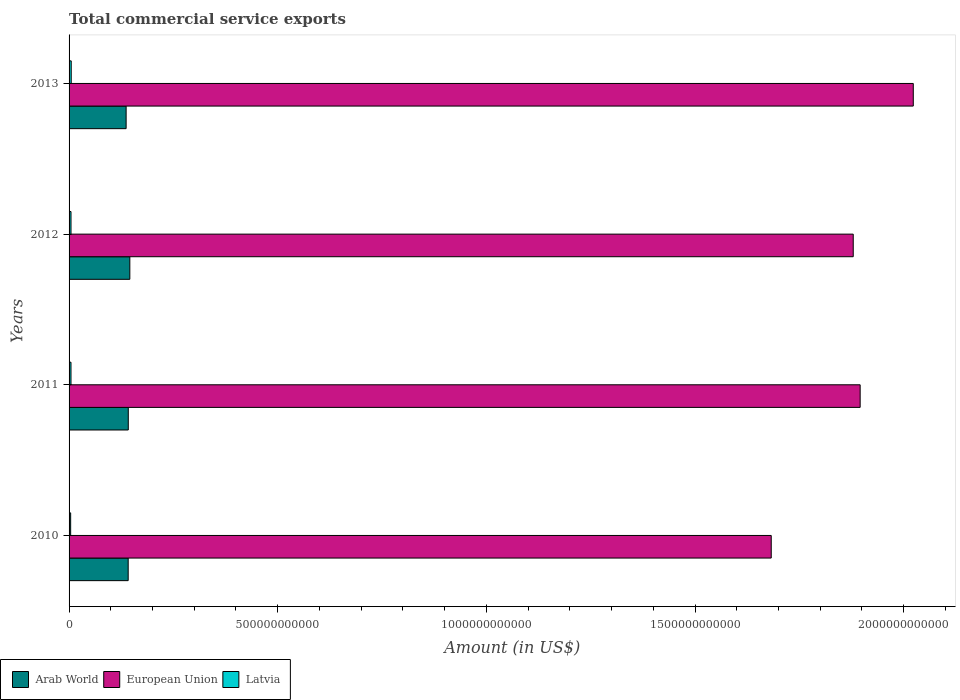How many different coloured bars are there?
Provide a succinct answer. 3. Are the number of bars per tick equal to the number of legend labels?
Make the answer very short. Yes. How many bars are there on the 4th tick from the top?
Make the answer very short. 3. How many bars are there on the 4th tick from the bottom?
Give a very brief answer. 3. What is the label of the 2nd group of bars from the top?
Make the answer very short. 2012. In how many cases, is the number of bars for a given year not equal to the number of legend labels?
Ensure brevity in your answer.  0. What is the total commercial service exports in European Union in 2012?
Make the answer very short. 1.88e+12. Across all years, what is the maximum total commercial service exports in Arab World?
Keep it short and to the point. 1.46e+11. Across all years, what is the minimum total commercial service exports in Latvia?
Your response must be concise. 3.78e+09. In which year was the total commercial service exports in Latvia minimum?
Your response must be concise. 2010. What is the total total commercial service exports in Arab World in the graph?
Provide a succinct answer. 5.66e+11. What is the difference between the total commercial service exports in Arab World in 2010 and that in 2013?
Your answer should be compact. 4.95e+09. What is the difference between the total commercial service exports in European Union in 2013 and the total commercial service exports in Arab World in 2012?
Provide a succinct answer. 1.88e+12. What is the average total commercial service exports in Latvia per year?
Your answer should be very brief. 4.54e+09. In the year 2012, what is the difference between the total commercial service exports in Latvia and total commercial service exports in European Union?
Your answer should be very brief. -1.87e+12. What is the ratio of the total commercial service exports in Arab World in 2012 to that in 2013?
Your answer should be very brief. 1.06. Is the difference between the total commercial service exports in Latvia in 2011 and 2012 greater than the difference between the total commercial service exports in European Union in 2011 and 2012?
Make the answer very short. No. What is the difference between the highest and the second highest total commercial service exports in European Union?
Your answer should be compact. 1.27e+11. What is the difference between the highest and the lowest total commercial service exports in Latvia?
Your response must be concise. 1.36e+09. Is the sum of the total commercial service exports in European Union in 2010 and 2011 greater than the maximum total commercial service exports in Latvia across all years?
Provide a short and direct response. Yes. What does the 1st bar from the top in 2012 represents?
Your answer should be compact. Latvia. What does the 3rd bar from the bottom in 2012 represents?
Provide a succinct answer. Latvia. How many bars are there?
Make the answer very short. 12. How many years are there in the graph?
Make the answer very short. 4. What is the difference between two consecutive major ticks on the X-axis?
Keep it short and to the point. 5.00e+11. Are the values on the major ticks of X-axis written in scientific E-notation?
Your answer should be compact. No. Does the graph contain grids?
Give a very brief answer. No. How many legend labels are there?
Provide a succinct answer. 3. What is the title of the graph?
Your answer should be compact. Total commercial service exports. What is the label or title of the Y-axis?
Offer a very short reply. Years. What is the Amount (in US$) of Arab World in 2010?
Keep it short and to the point. 1.42e+11. What is the Amount (in US$) of European Union in 2010?
Your answer should be compact. 1.68e+12. What is the Amount (in US$) in Latvia in 2010?
Your answer should be compact. 3.78e+09. What is the Amount (in US$) in Arab World in 2011?
Make the answer very short. 1.42e+11. What is the Amount (in US$) in European Union in 2011?
Your answer should be compact. 1.90e+12. What is the Amount (in US$) in Latvia in 2011?
Your answer should be compact. 4.58e+09. What is the Amount (in US$) in Arab World in 2012?
Your answer should be very brief. 1.46e+11. What is the Amount (in US$) in European Union in 2012?
Provide a short and direct response. 1.88e+12. What is the Amount (in US$) in Latvia in 2012?
Provide a short and direct response. 4.64e+09. What is the Amount (in US$) in Arab World in 2013?
Your answer should be compact. 1.37e+11. What is the Amount (in US$) of European Union in 2013?
Keep it short and to the point. 2.02e+12. What is the Amount (in US$) of Latvia in 2013?
Provide a succinct answer. 5.14e+09. Across all years, what is the maximum Amount (in US$) in Arab World?
Ensure brevity in your answer.  1.46e+11. Across all years, what is the maximum Amount (in US$) of European Union?
Offer a very short reply. 2.02e+12. Across all years, what is the maximum Amount (in US$) of Latvia?
Offer a terse response. 5.14e+09. Across all years, what is the minimum Amount (in US$) of Arab World?
Provide a succinct answer. 1.37e+11. Across all years, what is the minimum Amount (in US$) of European Union?
Give a very brief answer. 1.68e+12. Across all years, what is the minimum Amount (in US$) of Latvia?
Offer a terse response. 3.78e+09. What is the total Amount (in US$) of Arab World in the graph?
Make the answer very short. 5.66e+11. What is the total Amount (in US$) in European Union in the graph?
Your response must be concise. 7.48e+12. What is the total Amount (in US$) in Latvia in the graph?
Offer a terse response. 1.81e+1. What is the difference between the Amount (in US$) of Arab World in 2010 and that in 2011?
Give a very brief answer. -2.50e+08. What is the difference between the Amount (in US$) in European Union in 2010 and that in 2011?
Your answer should be compact. -2.13e+11. What is the difference between the Amount (in US$) in Latvia in 2010 and that in 2011?
Keep it short and to the point. -7.96e+08. What is the difference between the Amount (in US$) in Arab World in 2010 and that in 2012?
Offer a terse response. -3.93e+09. What is the difference between the Amount (in US$) of European Union in 2010 and that in 2012?
Ensure brevity in your answer.  -1.96e+11. What is the difference between the Amount (in US$) in Latvia in 2010 and that in 2012?
Make the answer very short. -8.55e+08. What is the difference between the Amount (in US$) in Arab World in 2010 and that in 2013?
Provide a short and direct response. 4.95e+09. What is the difference between the Amount (in US$) of European Union in 2010 and that in 2013?
Give a very brief answer. -3.40e+11. What is the difference between the Amount (in US$) of Latvia in 2010 and that in 2013?
Provide a succinct answer. -1.36e+09. What is the difference between the Amount (in US$) of Arab World in 2011 and that in 2012?
Offer a terse response. -3.68e+09. What is the difference between the Amount (in US$) in European Union in 2011 and that in 2012?
Your response must be concise. 1.66e+1. What is the difference between the Amount (in US$) of Latvia in 2011 and that in 2012?
Provide a short and direct response. -5.86e+07. What is the difference between the Amount (in US$) of Arab World in 2011 and that in 2013?
Ensure brevity in your answer.  5.20e+09. What is the difference between the Amount (in US$) in European Union in 2011 and that in 2013?
Ensure brevity in your answer.  -1.27e+11. What is the difference between the Amount (in US$) in Latvia in 2011 and that in 2013?
Make the answer very short. -5.62e+08. What is the difference between the Amount (in US$) of Arab World in 2012 and that in 2013?
Your answer should be very brief. 8.88e+09. What is the difference between the Amount (in US$) of European Union in 2012 and that in 2013?
Your answer should be compact. -1.44e+11. What is the difference between the Amount (in US$) in Latvia in 2012 and that in 2013?
Your answer should be very brief. -5.04e+08. What is the difference between the Amount (in US$) of Arab World in 2010 and the Amount (in US$) of European Union in 2011?
Offer a very short reply. -1.75e+12. What is the difference between the Amount (in US$) in Arab World in 2010 and the Amount (in US$) in Latvia in 2011?
Provide a succinct answer. 1.37e+11. What is the difference between the Amount (in US$) of European Union in 2010 and the Amount (in US$) of Latvia in 2011?
Give a very brief answer. 1.68e+12. What is the difference between the Amount (in US$) in Arab World in 2010 and the Amount (in US$) in European Union in 2012?
Make the answer very short. -1.74e+12. What is the difference between the Amount (in US$) of Arab World in 2010 and the Amount (in US$) of Latvia in 2012?
Ensure brevity in your answer.  1.37e+11. What is the difference between the Amount (in US$) in European Union in 2010 and the Amount (in US$) in Latvia in 2012?
Your answer should be very brief. 1.68e+12. What is the difference between the Amount (in US$) of Arab World in 2010 and the Amount (in US$) of European Union in 2013?
Offer a terse response. -1.88e+12. What is the difference between the Amount (in US$) of Arab World in 2010 and the Amount (in US$) of Latvia in 2013?
Your answer should be very brief. 1.37e+11. What is the difference between the Amount (in US$) of European Union in 2010 and the Amount (in US$) of Latvia in 2013?
Your answer should be very brief. 1.68e+12. What is the difference between the Amount (in US$) of Arab World in 2011 and the Amount (in US$) of European Union in 2012?
Make the answer very short. -1.74e+12. What is the difference between the Amount (in US$) in Arab World in 2011 and the Amount (in US$) in Latvia in 2012?
Provide a succinct answer. 1.37e+11. What is the difference between the Amount (in US$) of European Union in 2011 and the Amount (in US$) of Latvia in 2012?
Your answer should be compact. 1.89e+12. What is the difference between the Amount (in US$) of Arab World in 2011 and the Amount (in US$) of European Union in 2013?
Ensure brevity in your answer.  -1.88e+12. What is the difference between the Amount (in US$) of Arab World in 2011 and the Amount (in US$) of Latvia in 2013?
Ensure brevity in your answer.  1.37e+11. What is the difference between the Amount (in US$) of European Union in 2011 and the Amount (in US$) of Latvia in 2013?
Offer a terse response. 1.89e+12. What is the difference between the Amount (in US$) in Arab World in 2012 and the Amount (in US$) in European Union in 2013?
Ensure brevity in your answer.  -1.88e+12. What is the difference between the Amount (in US$) in Arab World in 2012 and the Amount (in US$) in Latvia in 2013?
Offer a very short reply. 1.40e+11. What is the difference between the Amount (in US$) of European Union in 2012 and the Amount (in US$) of Latvia in 2013?
Make the answer very short. 1.87e+12. What is the average Amount (in US$) in Arab World per year?
Make the answer very short. 1.41e+11. What is the average Amount (in US$) in European Union per year?
Offer a very short reply. 1.87e+12. What is the average Amount (in US$) of Latvia per year?
Offer a terse response. 4.54e+09. In the year 2010, what is the difference between the Amount (in US$) of Arab World and Amount (in US$) of European Union?
Offer a terse response. -1.54e+12. In the year 2010, what is the difference between the Amount (in US$) in Arab World and Amount (in US$) in Latvia?
Your answer should be compact. 1.38e+11. In the year 2010, what is the difference between the Amount (in US$) of European Union and Amount (in US$) of Latvia?
Your answer should be very brief. 1.68e+12. In the year 2011, what is the difference between the Amount (in US$) in Arab World and Amount (in US$) in European Union?
Offer a very short reply. -1.75e+12. In the year 2011, what is the difference between the Amount (in US$) of Arab World and Amount (in US$) of Latvia?
Offer a terse response. 1.37e+11. In the year 2011, what is the difference between the Amount (in US$) in European Union and Amount (in US$) in Latvia?
Keep it short and to the point. 1.89e+12. In the year 2012, what is the difference between the Amount (in US$) in Arab World and Amount (in US$) in European Union?
Keep it short and to the point. -1.73e+12. In the year 2012, what is the difference between the Amount (in US$) of Arab World and Amount (in US$) of Latvia?
Provide a succinct answer. 1.41e+11. In the year 2012, what is the difference between the Amount (in US$) in European Union and Amount (in US$) in Latvia?
Offer a terse response. 1.87e+12. In the year 2013, what is the difference between the Amount (in US$) in Arab World and Amount (in US$) in European Union?
Make the answer very short. -1.89e+12. In the year 2013, what is the difference between the Amount (in US$) of Arab World and Amount (in US$) of Latvia?
Provide a succinct answer. 1.32e+11. In the year 2013, what is the difference between the Amount (in US$) in European Union and Amount (in US$) in Latvia?
Give a very brief answer. 2.02e+12. What is the ratio of the Amount (in US$) in European Union in 2010 to that in 2011?
Make the answer very short. 0.89. What is the ratio of the Amount (in US$) of Latvia in 2010 to that in 2011?
Offer a terse response. 0.83. What is the ratio of the Amount (in US$) of Arab World in 2010 to that in 2012?
Give a very brief answer. 0.97. What is the ratio of the Amount (in US$) of European Union in 2010 to that in 2012?
Ensure brevity in your answer.  0.9. What is the ratio of the Amount (in US$) of Latvia in 2010 to that in 2012?
Your answer should be compact. 0.82. What is the ratio of the Amount (in US$) of Arab World in 2010 to that in 2013?
Make the answer very short. 1.04. What is the ratio of the Amount (in US$) in European Union in 2010 to that in 2013?
Your answer should be very brief. 0.83. What is the ratio of the Amount (in US$) in Latvia in 2010 to that in 2013?
Your response must be concise. 0.74. What is the ratio of the Amount (in US$) in Arab World in 2011 to that in 2012?
Your response must be concise. 0.97. What is the ratio of the Amount (in US$) in European Union in 2011 to that in 2012?
Give a very brief answer. 1.01. What is the ratio of the Amount (in US$) in Latvia in 2011 to that in 2012?
Keep it short and to the point. 0.99. What is the ratio of the Amount (in US$) in Arab World in 2011 to that in 2013?
Keep it short and to the point. 1.04. What is the ratio of the Amount (in US$) in European Union in 2011 to that in 2013?
Provide a short and direct response. 0.94. What is the ratio of the Amount (in US$) in Latvia in 2011 to that in 2013?
Ensure brevity in your answer.  0.89. What is the ratio of the Amount (in US$) in Arab World in 2012 to that in 2013?
Provide a short and direct response. 1.06. What is the ratio of the Amount (in US$) of European Union in 2012 to that in 2013?
Your answer should be very brief. 0.93. What is the ratio of the Amount (in US$) of Latvia in 2012 to that in 2013?
Make the answer very short. 0.9. What is the difference between the highest and the second highest Amount (in US$) in Arab World?
Offer a terse response. 3.68e+09. What is the difference between the highest and the second highest Amount (in US$) of European Union?
Keep it short and to the point. 1.27e+11. What is the difference between the highest and the second highest Amount (in US$) of Latvia?
Your response must be concise. 5.04e+08. What is the difference between the highest and the lowest Amount (in US$) of Arab World?
Keep it short and to the point. 8.88e+09. What is the difference between the highest and the lowest Amount (in US$) in European Union?
Your response must be concise. 3.40e+11. What is the difference between the highest and the lowest Amount (in US$) in Latvia?
Offer a terse response. 1.36e+09. 